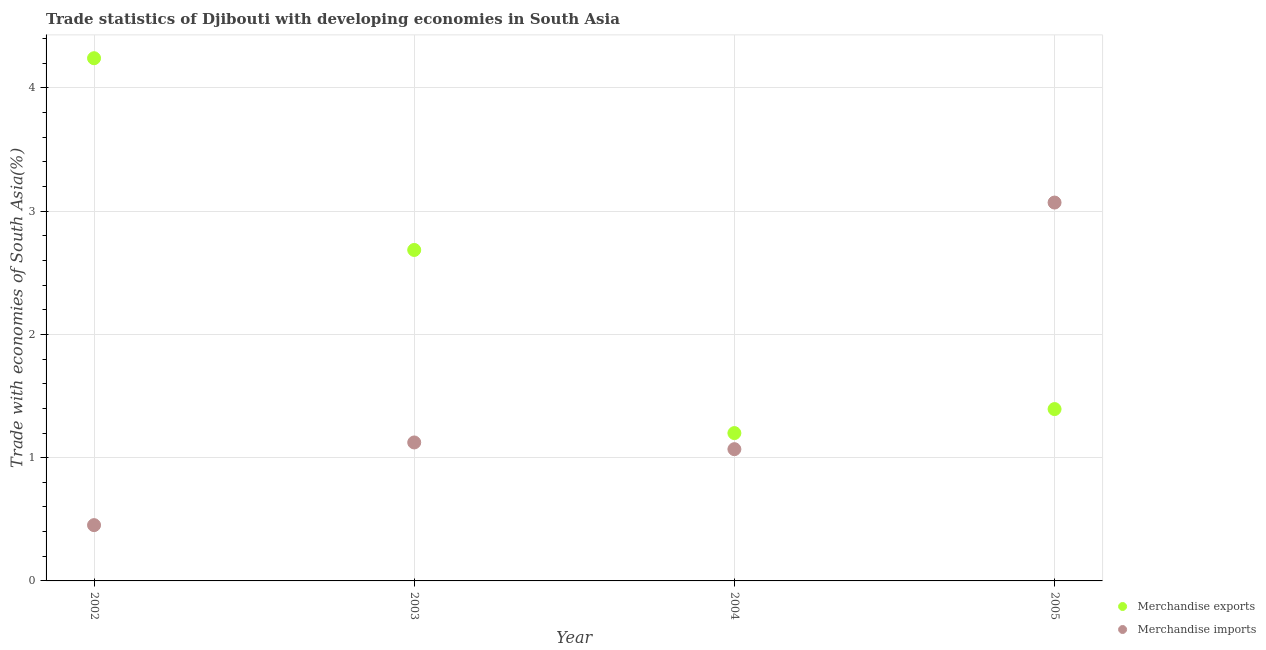How many different coloured dotlines are there?
Offer a very short reply. 2. Is the number of dotlines equal to the number of legend labels?
Provide a succinct answer. Yes. What is the merchandise imports in 2004?
Your answer should be compact. 1.07. Across all years, what is the maximum merchandise exports?
Your answer should be compact. 4.24. Across all years, what is the minimum merchandise exports?
Make the answer very short. 1.2. What is the total merchandise imports in the graph?
Your answer should be compact. 5.71. What is the difference between the merchandise exports in 2004 and that in 2005?
Make the answer very short. -0.19. What is the difference between the merchandise exports in 2002 and the merchandise imports in 2004?
Keep it short and to the point. 3.17. What is the average merchandise imports per year?
Your answer should be very brief. 1.43. In the year 2002, what is the difference between the merchandise imports and merchandise exports?
Your answer should be compact. -3.79. What is the ratio of the merchandise exports in 2004 to that in 2005?
Make the answer very short. 0.86. Is the difference between the merchandise imports in 2002 and 2005 greater than the difference between the merchandise exports in 2002 and 2005?
Your answer should be compact. No. What is the difference between the highest and the second highest merchandise exports?
Provide a succinct answer. 1.56. What is the difference between the highest and the lowest merchandise imports?
Provide a short and direct response. 2.62. In how many years, is the merchandise exports greater than the average merchandise exports taken over all years?
Ensure brevity in your answer.  2. Is the sum of the merchandise exports in 2002 and 2005 greater than the maximum merchandise imports across all years?
Offer a very short reply. Yes. Is the merchandise exports strictly less than the merchandise imports over the years?
Give a very brief answer. No. How many dotlines are there?
Your answer should be very brief. 2. Does the graph contain grids?
Offer a terse response. Yes. How many legend labels are there?
Offer a terse response. 2. What is the title of the graph?
Provide a succinct answer. Trade statistics of Djibouti with developing economies in South Asia. What is the label or title of the X-axis?
Offer a very short reply. Year. What is the label or title of the Y-axis?
Provide a short and direct response. Trade with economies of South Asia(%). What is the Trade with economies of South Asia(%) in Merchandise exports in 2002?
Offer a very short reply. 4.24. What is the Trade with economies of South Asia(%) of Merchandise imports in 2002?
Provide a succinct answer. 0.45. What is the Trade with economies of South Asia(%) of Merchandise exports in 2003?
Offer a very short reply. 2.68. What is the Trade with economies of South Asia(%) of Merchandise imports in 2003?
Give a very brief answer. 1.12. What is the Trade with economies of South Asia(%) in Merchandise exports in 2004?
Offer a very short reply. 1.2. What is the Trade with economies of South Asia(%) of Merchandise imports in 2004?
Provide a succinct answer. 1.07. What is the Trade with economies of South Asia(%) in Merchandise exports in 2005?
Your answer should be very brief. 1.39. What is the Trade with economies of South Asia(%) in Merchandise imports in 2005?
Provide a short and direct response. 3.07. Across all years, what is the maximum Trade with economies of South Asia(%) of Merchandise exports?
Your response must be concise. 4.24. Across all years, what is the maximum Trade with economies of South Asia(%) in Merchandise imports?
Your answer should be compact. 3.07. Across all years, what is the minimum Trade with economies of South Asia(%) of Merchandise exports?
Ensure brevity in your answer.  1.2. Across all years, what is the minimum Trade with economies of South Asia(%) of Merchandise imports?
Ensure brevity in your answer.  0.45. What is the total Trade with economies of South Asia(%) in Merchandise exports in the graph?
Offer a terse response. 9.52. What is the total Trade with economies of South Asia(%) of Merchandise imports in the graph?
Offer a very short reply. 5.71. What is the difference between the Trade with economies of South Asia(%) of Merchandise exports in 2002 and that in 2003?
Your answer should be very brief. 1.56. What is the difference between the Trade with economies of South Asia(%) of Merchandise imports in 2002 and that in 2003?
Your response must be concise. -0.67. What is the difference between the Trade with economies of South Asia(%) in Merchandise exports in 2002 and that in 2004?
Make the answer very short. 3.04. What is the difference between the Trade with economies of South Asia(%) in Merchandise imports in 2002 and that in 2004?
Offer a terse response. -0.62. What is the difference between the Trade with economies of South Asia(%) of Merchandise exports in 2002 and that in 2005?
Provide a short and direct response. 2.85. What is the difference between the Trade with economies of South Asia(%) in Merchandise imports in 2002 and that in 2005?
Make the answer very short. -2.62. What is the difference between the Trade with economies of South Asia(%) in Merchandise exports in 2003 and that in 2004?
Make the answer very short. 1.49. What is the difference between the Trade with economies of South Asia(%) in Merchandise imports in 2003 and that in 2004?
Your answer should be compact. 0.05. What is the difference between the Trade with economies of South Asia(%) of Merchandise exports in 2003 and that in 2005?
Offer a very short reply. 1.29. What is the difference between the Trade with economies of South Asia(%) in Merchandise imports in 2003 and that in 2005?
Give a very brief answer. -1.95. What is the difference between the Trade with economies of South Asia(%) of Merchandise exports in 2004 and that in 2005?
Ensure brevity in your answer.  -0.19. What is the difference between the Trade with economies of South Asia(%) in Merchandise imports in 2004 and that in 2005?
Provide a short and direct response. -2. What is the difference between the Trade with economies of South Asia(%) in Merchandise exports in 2002 and the Trade with economies of South Asia(%) in Merchandise imports in 2003?
Offer a very short reply. 3.12. What is the difference between the Trade with economies of South Asia(%) in Merchandise exports in 2002 and the Trade with economies of South Asia(%) in Merchandise imports in 2004?
Provide a short and direct response. 3.17. What is the difference between the Trade with economies of South Asia(%) in Merchandise exports in 2002 and the Trade with economies of South Asia(%) in Merchandise imports in 2005?
Ensure brevity in your answer.  1.17. What is the difference between the Trade with economies of South Asia(%) of Merchandise exports in 2003 and the Trade with economies of South Asia(%) of Merchandise imports in 2004?
Your answer should be compact. 1.62. What is the difference between the Trade with economies of South Asia(%) of Merchandise exports in 2003 and the Trade with economies of South Asia(%) of Merchandise imports in 2005?
Provide a succinct answer. -0.38. What is the difference between the Trade with economies of South Asia(%) in Merchandise exports in 2004 and the Trade with economies of South Asia(%) in Merchandise imports in 2005?
Keep it short and to the point. -1.87. What is the average Trade with economies of South Asia(%) in Merchandise exports per year?
Offer a terse response. 2.38. What is the average Trade with economies of South Asia(%) in Merchandise imports per year?
Offer a terse response. 1.43. In the year 2002, what is the difference between the Trade with economies of South Asia(%) of Merchandise exports and Trade with economies of South Asia(%) of Merchandise imports?
Offer a very short reply. 3.79. In the year 2003, what is the difference between the Trade with economies of South Asia(%) of Merchandise exports and Trade with economies of South Asia(%) of Merchandise imports?
Provide a short and direct response. 1.56. In the year 2004, what is the difference between the Trade with economies of South Asia(%) of Merchandise exports and Trade with economies of South Asia(%) of Merchandise imports?
Offer a very short reply. 0.13. In the year 2005, what is the difference between the Trade with economies of South Asia(%) of Merchandise exports and Trade with economies of South Asia(%) of Merchandise imports?
Offer a very short reply. -1.68. What is the ratio of the Trade with economies of South Asia(%) of Merchandise exports in 2002 to that in 2003?
Offer a terse response. 1.58. What is the ratio of the Trade with economies of South Asia(%) of Merchandise imports in 2002 to that in 2003?
Keep it short and to the point. 0.4. What is the ratio of the Trade with economies of South Asia(%) in Merchandise exports in 2002 to that in 2004?
Ensure brevity in your answer.  3.54. What is the ratio of the Trade with economies of South Asia(%) in Merchandise imports in 2002 to that in 2004?
Give a very brief answer. 0.42. What is the ratio of the Trade with economies of South Asia(%) in Merchandise exports in 2002 to that in 2005?
Your response must be concise. 3.04. What is the ratio of the Trade with economies of South Asia(%) in Merchandise imports in 2002 to that in 2005?
Provide a succinct answer. 0.15. What is the ratio of the Trade with economies of South Asia(%) in Merchandise exports in 2003 to that in 2004?
Keep it short and to the point. 2.24. What is the ratio of the Trade with economies of South Asia(%) of Merchandise imports in 2003 to that in 2004?
Your response must be concise. 1.05. What is the ratio of the Trade with economies of South Asia(%) of Merchandise exports in 2003 to that in 2005?
Make the answer very short. 1.93. What is the ratio of the Trade with economies of South Asia(%) of Merchandise imports in 2003 to that in 2005?
Your answer should be compact. 0.37. What is the ratio of the Trade with economies of South Asia(%) in Merchandise exports in 2004 to that in 2005?
Keep it short and to the point. 0.86. What is the ratio of the Trade with economies of South Asia(%) in Merchandise imports in 2004 to that in 2005?
Make the answer very short. 0.35. What is the difference between the highest and the second highest Trade with economies of South Asia(%) of Merchandise exports?
Provide a short and direct response. 1.56. What is the difference between the highest and the second highest Trade with economies of South Asia(%) in Merchandise imports?
Give a very brief answer. 1.95. What is the difference between the highest and the lowest Trade with economies of South Asia(%) of Merchandise exports?
Ensure brevity in your answer.  3.04. What is the difference between the highest and the lowest Trade with economies of South Asia(%) in Merchandise imports?
Your answer should be very brief. 2.62. 